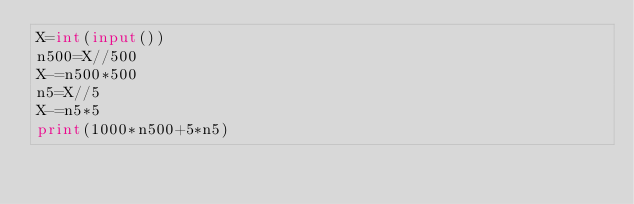Convert code to text. <code><loc_0><loc_0><loc_500><loc_500><_Python_>X=int(input())
n500=X//500
X-=n500*500
n5=X//5
X-=n5*5
print(1000*n500+5*n5)</code> 